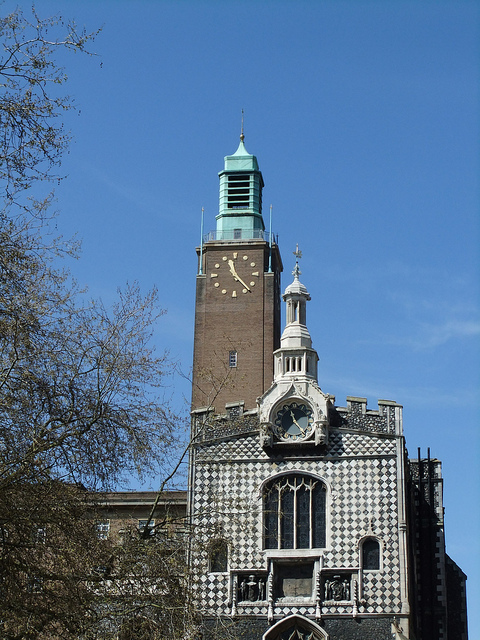<image>What religion is practiced at this church? I am not sure what religion is practiced at this church. It can be Christianity, Catholicism or Methodist. What is the blue object on the top of the building? I don't know what the blue object on the top of the building is. It could be a steeple, vent, clock tower, belltower, cupola, or peak. What religion is practiced at this church? It is not sure what religion is practiced at this church. However, it can be seen that Christianity is one of the possibilities. What is the blue object on the top of the building? I don't know what the blue object on the top of the building is. It can be a steeple, vent, clock tower, belltower, cupola, or peak. 